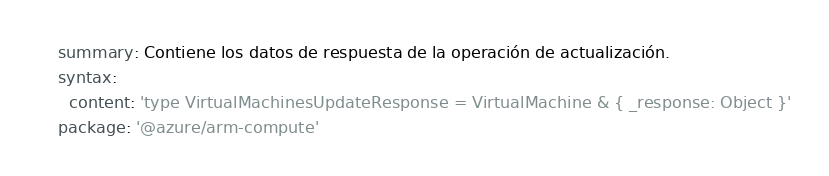Convert code to text. <code><loc_0><loc_0><loc_500><loc_500><_YAML_>    summary: Contiene los datos de respuesta de la operación de actualización.
    syntax:
      content: 'type VirtualMachinesUpdateResponse = VirtualMachine & { _response: Object }'
    package: '@azure/arm-compute'</code> 